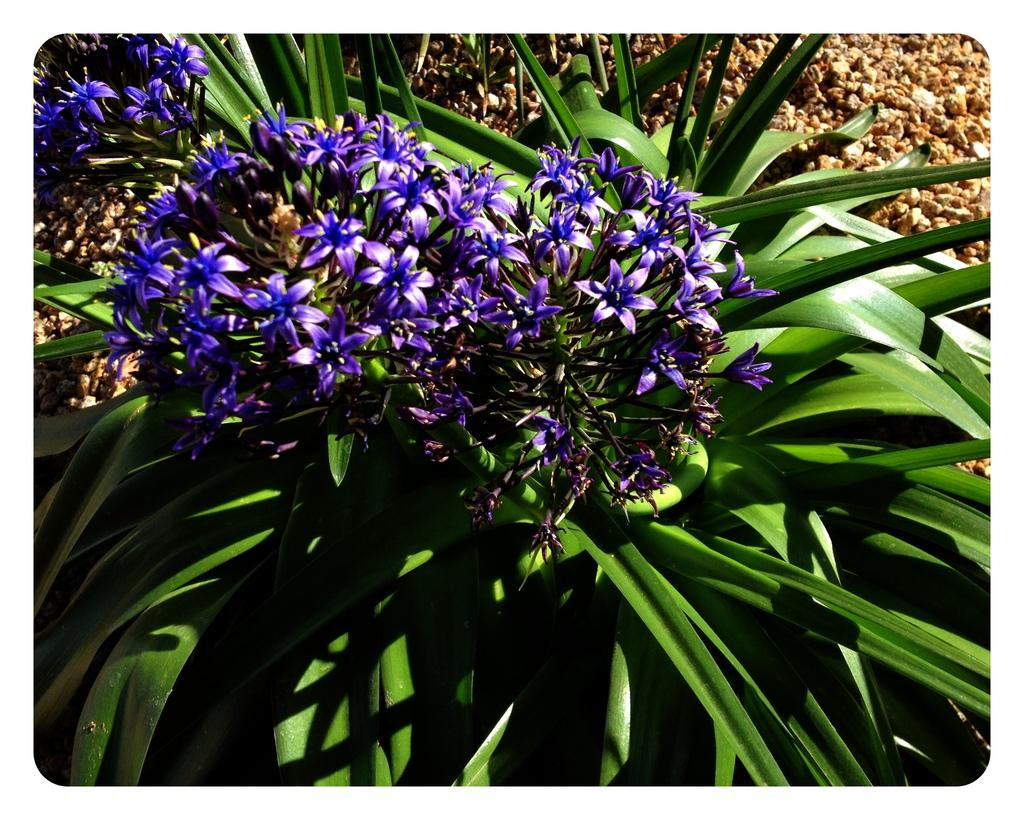What type of living organisms can be seen in the image? Plants can be seen in the image. Are there any specific features of the plants that are visible? Yes, there are flowers visible on the plants. What type of quartz can be seen in the image? There is no quartz present in the image. Is there a pipe visible in the image? No, there is no pipe visible in the image. What type of underwear is being worn by the plants in the image? Plants do not wear underwear, so this question cannot be answered. 